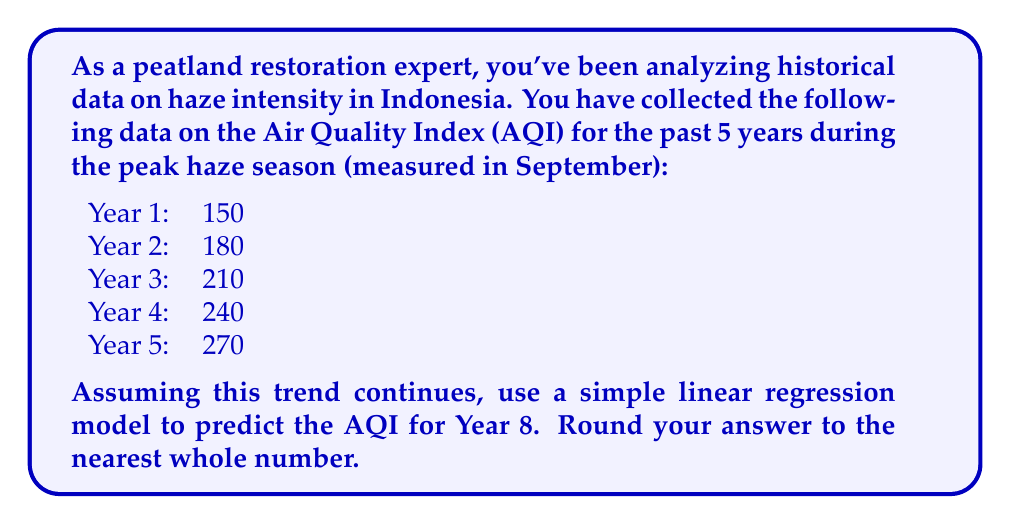Teach me how to tackle this problem. To predict the AQI for Year 8 using a simple linear regression model, we'll follow these steps:

1) First, let's set up our data:
   x (years): 1, 2, 3, 4, 5
   y (AQI): 150, 180, 210, 240, 270

2) We need to calculate the following:
   $\bar{x}$ (mean of x), $\bar{y}$ (mean of y), $\sum{xy}$, $\sum{x^2}$

   $\bar{x} = \frac{1+2+3+4+5}{5} = 3$
   $\bar{y} = \frac{150+180+210+240+270}{5} = 210$

   $\sum{xy} = 1(150) + 2(180) + 3(210) + 4(240) + 5(270) = 3300$
   $\sum{x^2} = 1^2 + 2^2 + 3^2 + 4^2 + 5^2 = 55$

3) Now we can calculate the slope (m) and y-intercept (b) of our regression line:

   $m = \frac{n\sum{xy} - \sum{x}\sum{y}}{n\sum{x^2} - (\sum{x})^2}$

   $m = \frac{5(3300) - (15)(210)}{5(55) - (15)^2} = \frac{16500 - 3150}{275 - 225} = \frac{13350}{50} = 30$

   $b = \bar{y} - m\bar{x} = 210 - 30(3) = 120$

4) Our regression equation is therefore:
   $y = 30x + 120$

5) To predict Year 8, we substitute x = 8:
   $y = 30(8) + 120 = 240 + 120 = 360$

Therefore, the predicted AQI for Year 8 is 360.
Answer: 360 